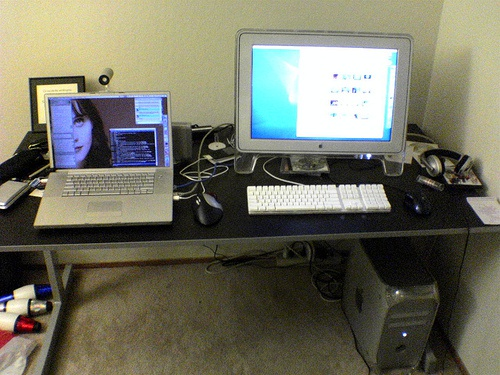Describe the objects in this image and their specific colors. I can see tv in beige, white, darkgray, and cyan tones, laptop in beige, darkgray, black, gray, and tan tones, keyboard in beige, darkgray, tan, and gray tones, keyboard in beige, lightgray, darkgray, gray, and black tones, and mouse in beige, black, and gray tones in this image. 